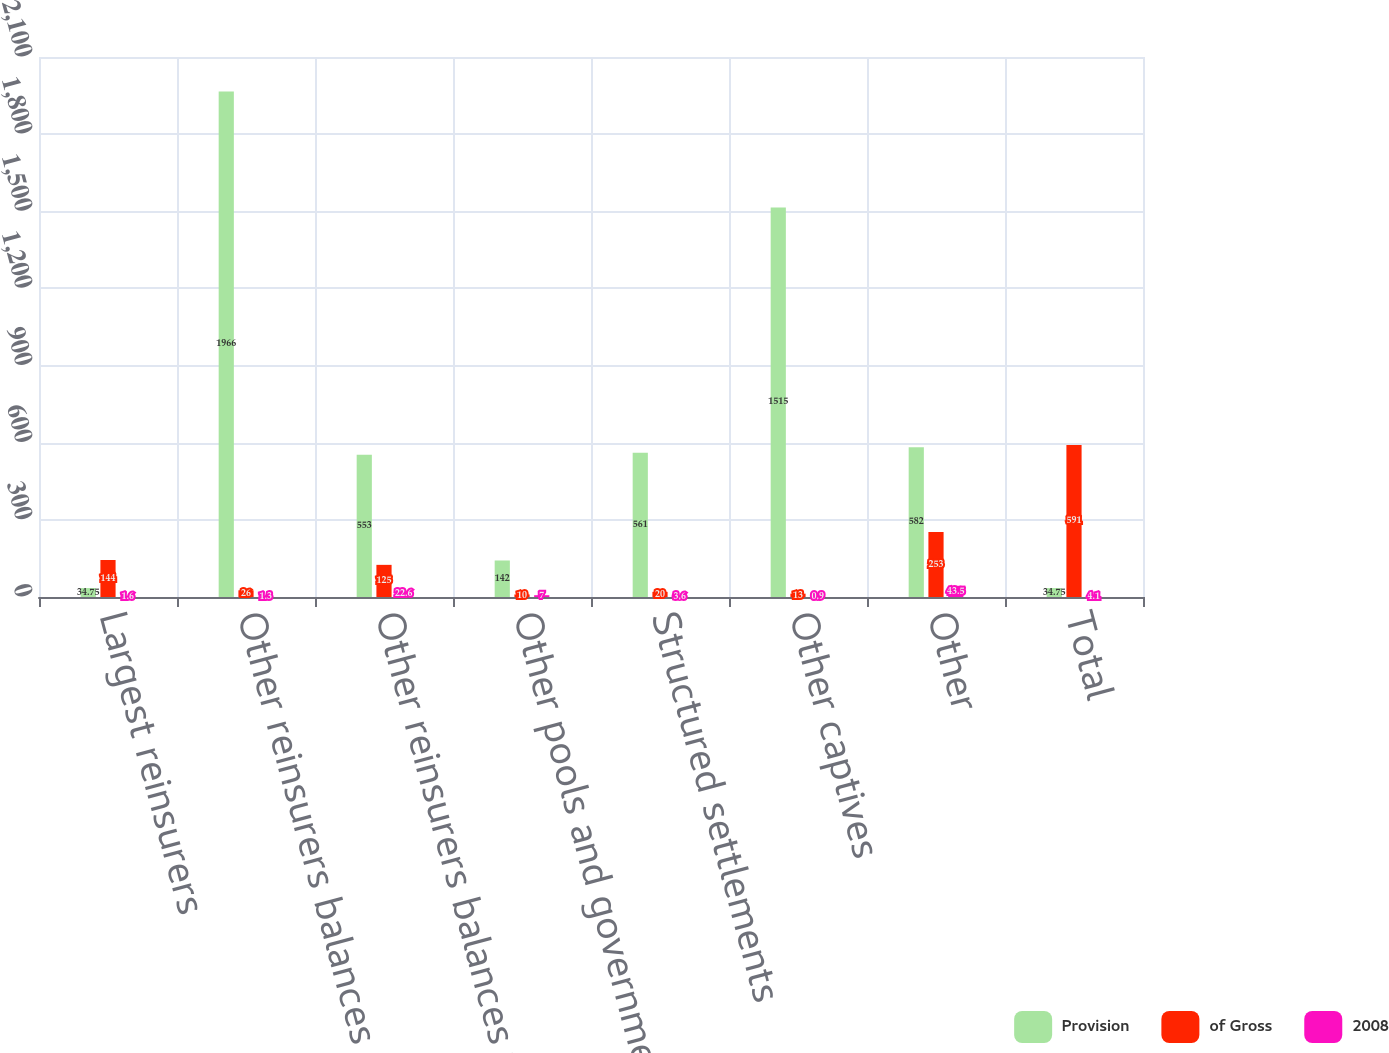Convert chart. <chart><loc_0><loc_0><loc_500><loc_500><stacked_bar_chart><ecel><fcel>Largest reinsurers<fcel>Other reinsurers balances<fcel>Other reinsurers balances with<fcel>Other pools and government<fcel>Structured settlements<fcel>Other captives<fcel>Other<fcel>Total<nl><fcel>Provision<fcel>34.75<fcel>1966<fcel>553<fcel>142<fcel>561<fcel>1515<fcel>582<fcel>34.75<nl><fcel>of Gross<fcel>144<fcel>26<fcel>125<fcel>10<fcel>20<fcel>13<fcel>253<fcel>591<nl><fcel>2008<fcel>1.6<fcel>1.3<fcel>22.6<fcel>7<fcel>3.6<fcel>0.9<fcel>43.5<fcel>4.1<nl></chart> 